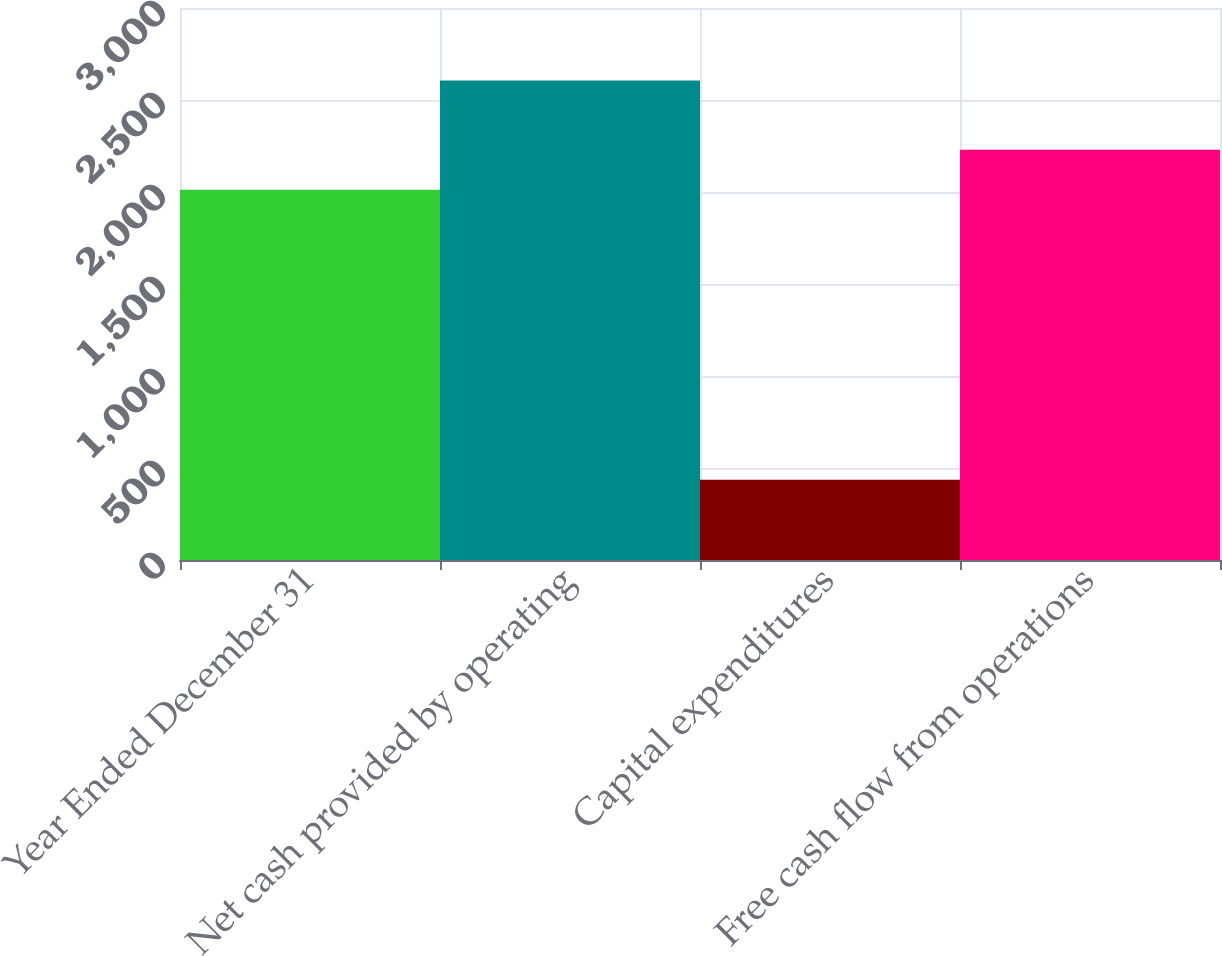<chart> <loc_0><loc_0><loc_500><loc_500><bar_chart><fcel>Year Ended December 31<fcel>Net cash provided by operating<fcel>Capital expenditures<fcel>Free cash flow from operations<nl><fcel>2012<fcel>2606<fcel>436<fcel>2229<nl></chart> 